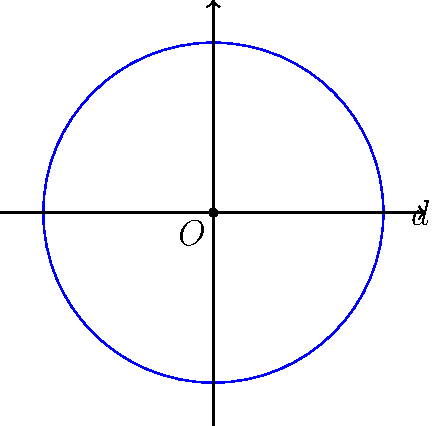After a long shift at the hospital, you're reviewing some engineering concepts for a side project. Calculate the cross-sectional area of a circular water pipe with a diameter of 0.5 meters. Round your answer to two decimal places. To find the cross-sectional area of a circular pipe, we can follow these steps:

1. Recall the formula for the area of a circle:
   $$A = \pi r^2$$
   where $A$ is the area and $r$ is the radius.

2. We are given the diameter $d = 0.5$ meters. The radius is half of the diameter:
   $$r = \frac{d}{2} = \frac{0.5}{2} = 0.25 \text{ meters}$$

3. Now, let's substitute this into our area formula:
   $$A = \pi (0.25)^2$$

4. Calculate:
   $$A = \pi (0.0625) \approx 0.1963 \text{ square meters}$$

5. Rounding to two decimal places:
   $$A \approx 0.20 \text{ square meters}$$
Answer: $0.20 \text{ m}^2$ 